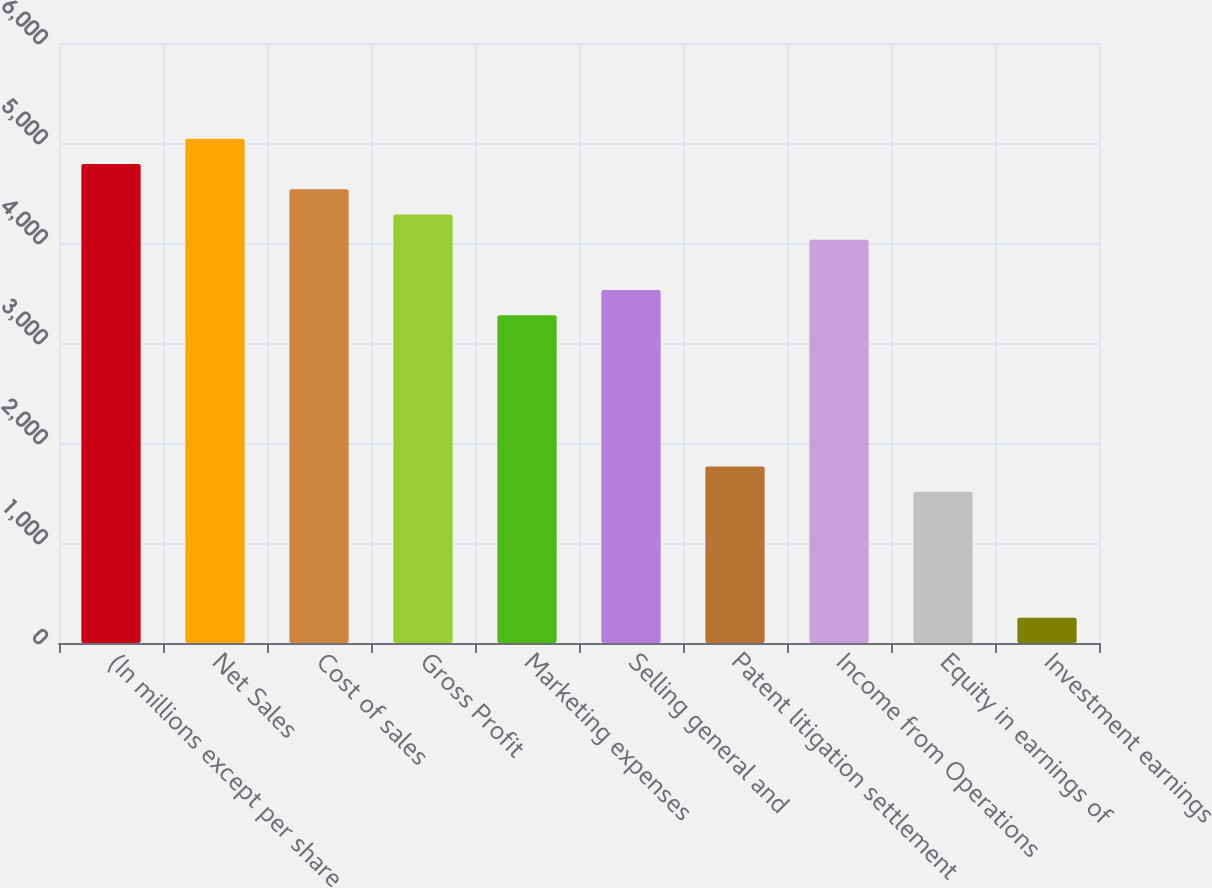Convert chart. <chart><loc_0><loc_0><loc_500><loc_500><bar_chart><fcel>(In millions except per share<fcel>Net Sales<fcel>Cost of sales<fcel>Gross Profit<fcel>Marketing expenses<fcel>Selling general and<fcel>Patent litigation settlement<fcel>Income from Operations<fcel>Equity in earnings of<fcel>Investment earnings<nl><fcel>4789.56<fcel>5041.63<fcel>4537.49<fcel>4285.42<fcel>3277.14<fcel>3529.21<fcel>1764.72<fcel>4033.35<fcel>1512.65<fcel>252.3<nl></chart> 